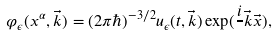<formula> <loc_0><loc_0><loc_500><loc_500>\varphi _ { \epsilon } ( x ^ { \alpha } , \vec { k } ) = ( 2 \pi \hbar { ) } ^ { - 3 / 2 } u _ { \epsilon } ( t , \vec { k } ) \exp ( { \frac { i } { } \vec { k } \vec { x } } ) ,</formula> 